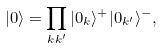Convert formula to latex. <formula><loc_0><loc_0><loc_500><loc_500>| 0 \rangle = \prod _ { k k ^ { \prime } } | 0 _ { k } \rangle ^ { + } | 0 _ { k ^ { \prime } } \rangle ^ { - } ,</formula> 